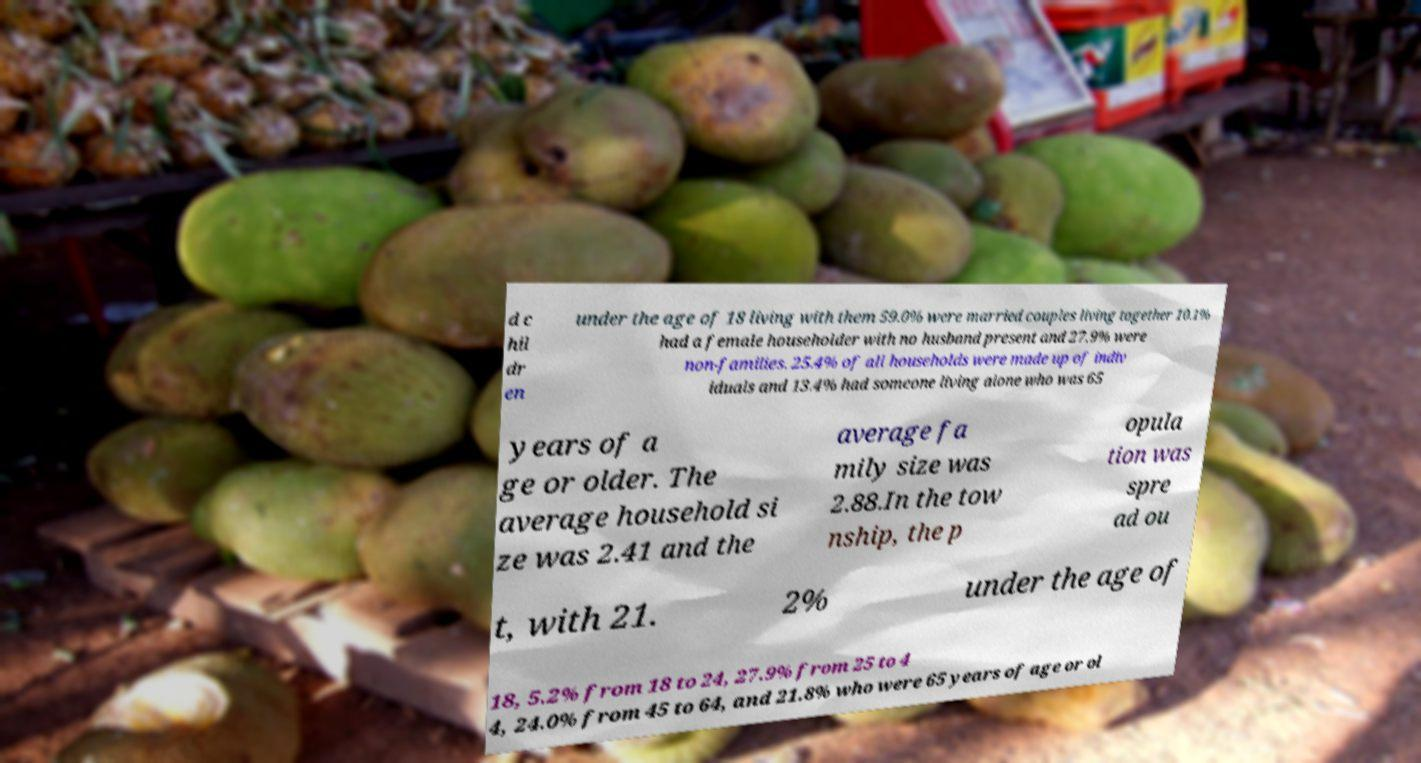There's text embedded in this image that I need extracted. Can you transcribe it verbatim? d c hil dr en under the age of 18 living with them 59.0% were married couples living together 10.1% had a female householder with no husband present and 27.9% were non-families. 25.4% of all households were made up of indiv iduals and 13.4% had someone living alone who was 65 years of a ge or older. The average household si ze was 2.41 and the average fa mily size was 2.88.In the tow nship, the p opula tion was spre ad ou t, with 21. 2% under the age of 18, 5.2% from 18 to 24, 27.9% from 25 to 4 4, 24.0% from 45 to 64, and 21.8% who were 65 years of age or ol 